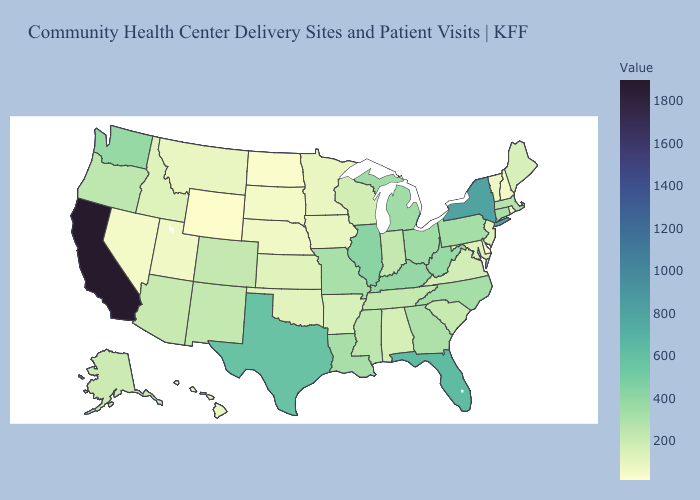Among the states that border Texas , which have the lowest value?
Answer briefly. Oklahoma. Among the states that border Indiana , does Kentucky have the lowest value?
Short answer required. No. Among the states that border Connecticut , which have the lowest value?
Give a very brief answer. Rhode Island. Among the states that border Connecticut , which have the highest value?
Short answer required. New York. Among the states that border Kansas , which have the lowest value?
Short answer required. Nebraska. Does the map have missing data?
Quick response, please. No. 